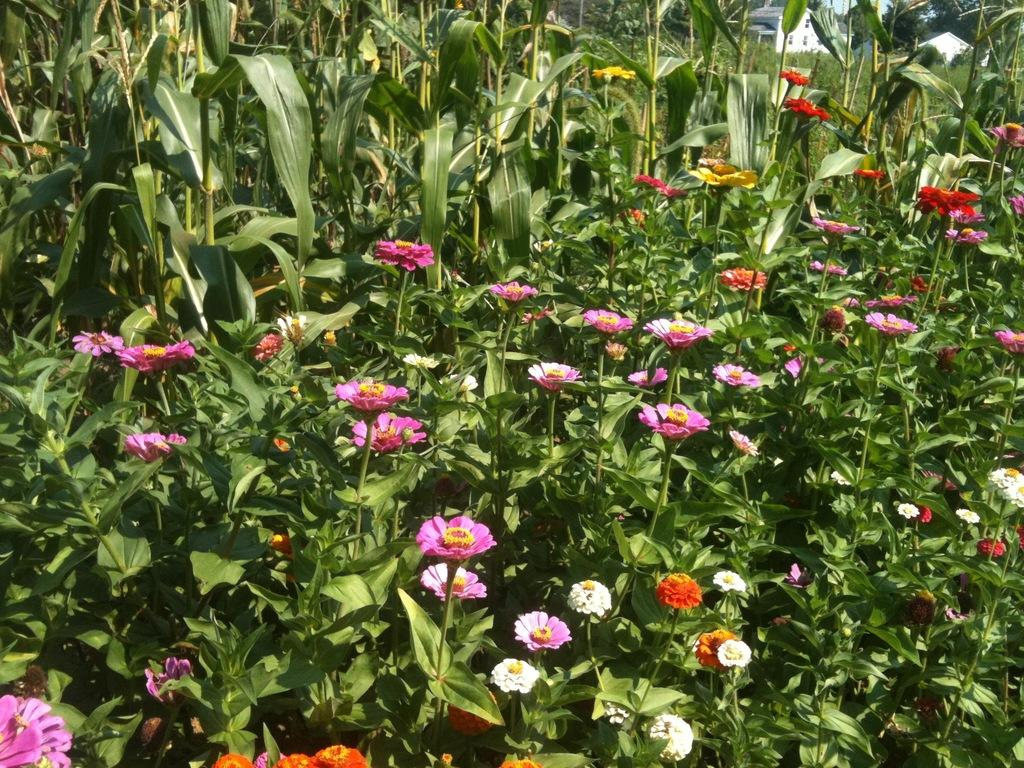What celestial bodies are depicted in the image? There are planets in the image. What types of flowers can be seen in the image? There are pink, orange, white, and red flowers in the image. Can you describe the background of the image? In the top right of the image, there is a house in the background. What type of clam is visible in the image? There is no clam present in the image. What word is written on the largest planet in the image? There are no words written on the planets in the image; they are depicted as natural celestial bodies. 